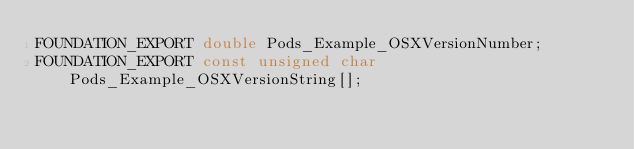<code> <loc_0><loc_0><loc_500><loc_500><_C_>FOUNDATION_EXPORT double Pods_Example_OSXVersionNumber;
FOUNDATION_EXPORT const unsigned char Pods_Example_OSXVersionString[];

</code> 